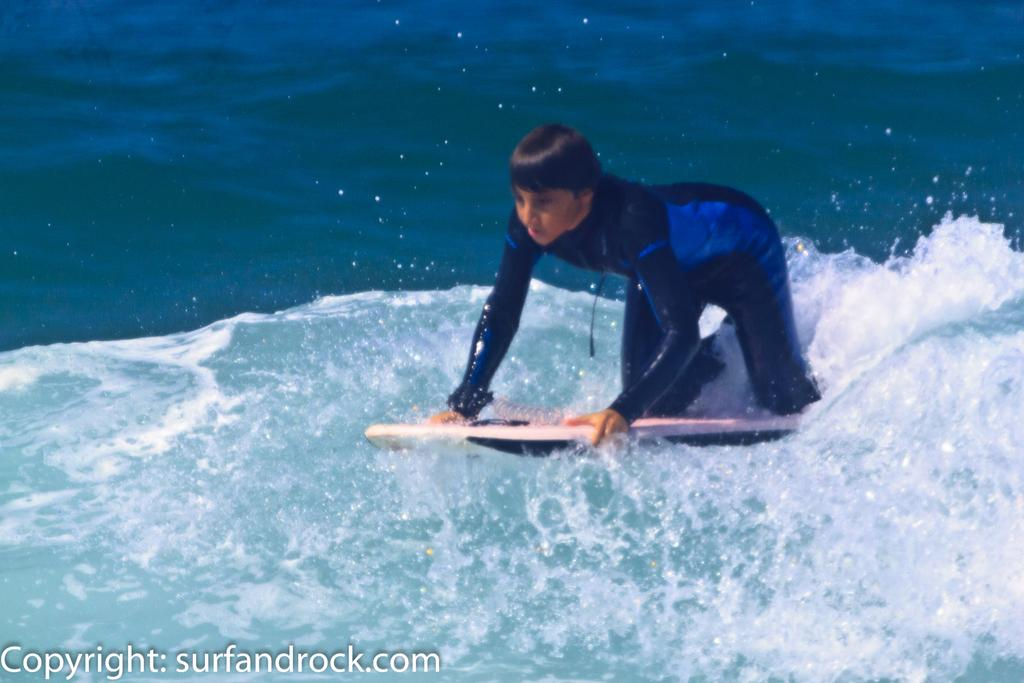Who is present in the image? There is a person in the image. What is the person holding in his hands? The person is holding a diving device in his hands. What can be seen in the background of the image? There is water visible in the image. How many daughters can be seen in the image? There are no daughters present in the image; it features a person holding a diving device. What type of cattle is visible in the image? There is no cattle present in the image; it features a person holding a diving device and water in the background. 